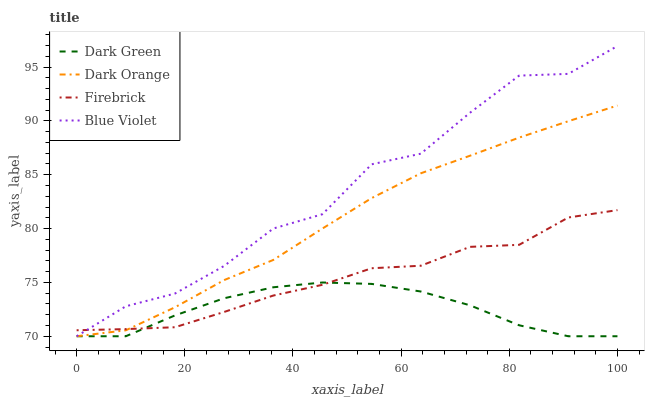Does Dark Green have the minimum area under the curve?
Answer yes or no. Yes. Does Blue Violet have the maximum area under the curve?
Answer yes or no. Yes. Does Firebrick have the minimum area under the curve?
Answer yes or no. No. Does Firebrick have the maximum area under the curve?
Answer yes or no. No. Is Dark Orange the smoothest?
Answer yes or no. Yes. Is Blue Violet the roughest?
Answer yes or no. Yes. Is Firebrick the smoothest?
Answer yes or no. No. Is Firebrick the roughest?
Answer yes or no. No. Does Dark Orange have the lowest value?
Answer yes or no. Yes. Does Firebrick have the lowest value?
Answer yes or no. No. Does Blue Violet have the highest value?
Answer yes or no. Yes. Does Firebrick have the highest value?
Answer yes or no. No. Does Firebrick intersect Dark Orange?
Answer yes or no. Yes. Is Firebrick less than Dark Orange?
Answer yes or no. No. Is Firebrick greater than Dark Orange?
Answer yes or no. No. 